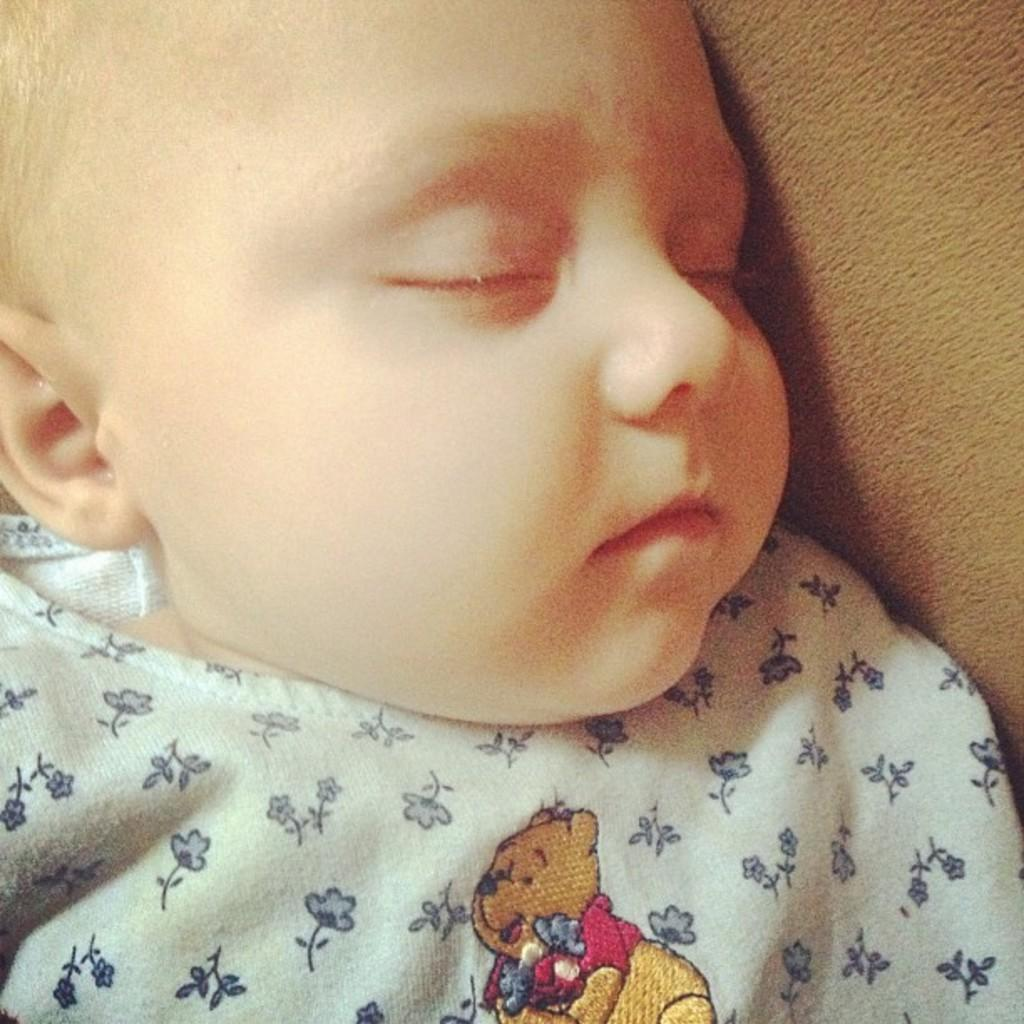What is the main subject of the image? The main subject of the image is a kid. What is the kid's position in the image? The kid is lying on a cloth. What type of vegetable is the kid holding in the image? There is no vegetable present in the image. Is the kid asking for help in the image? There is no indication in the image that the kid is asking for help. Is it raining in the image? There is no indication of rain or weather conditions in the image. 